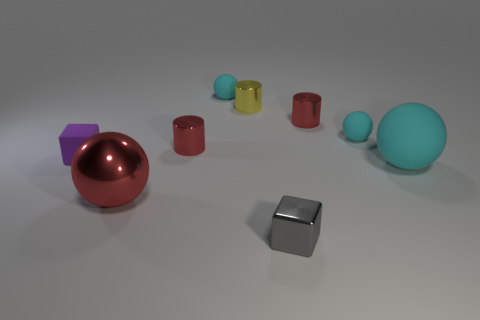How many cyan balls must be subtracted to get 1 cyan balls? 2 Subtract all red spheres. How many red cylinders are left? 2 Subtract all large rubber balls. How many balls are left? 3 Subtract all red spheres. How many spheres are left? 3 Subtract all green cylinders. Subtract all purple balls. How many cylinders are left? 3 Subtract 0 green cylinders. How many objects are left? 9 Subtract all cylinders. How many objects are left? 6 Subtract all small gray cubes. Subtract all cyan matte objects. How many objects are left? 5 Add 2 gray metal objects. How many gray metal objects are left? 3 Add 3 big cyan matte spheres. How many big cyan matte spheres exist? 4 